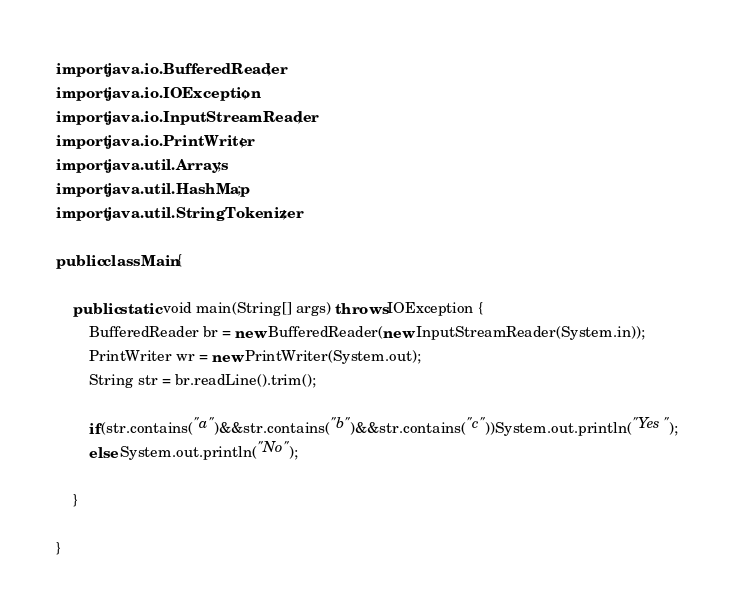Convert code to text. <code><loc_0><loc_0><loc_500><loc_500><_Java_>import java.io.BufferedReader;
import java.io.IOException;
import java.io.InputStreamReader;
import java.io.PrintWriter;
import java.util.Arrays;
import java.util.HashMap;
import java.util.StringTokenizer;

public class Main{

	public static void main(String[] args) throws IOException {
		BufferedReader br = new BufferedReader(new InputStreamReader(System.in));
        PrintWriter wr = new PrintWriter(System.out);
        String str = br.readLine().trim();
        
        if(str.contains("a")&&str.contains("b")&&str.contains("c"))System.out.println("Yes");
        else System.out.println("No");

	}

}</code> 